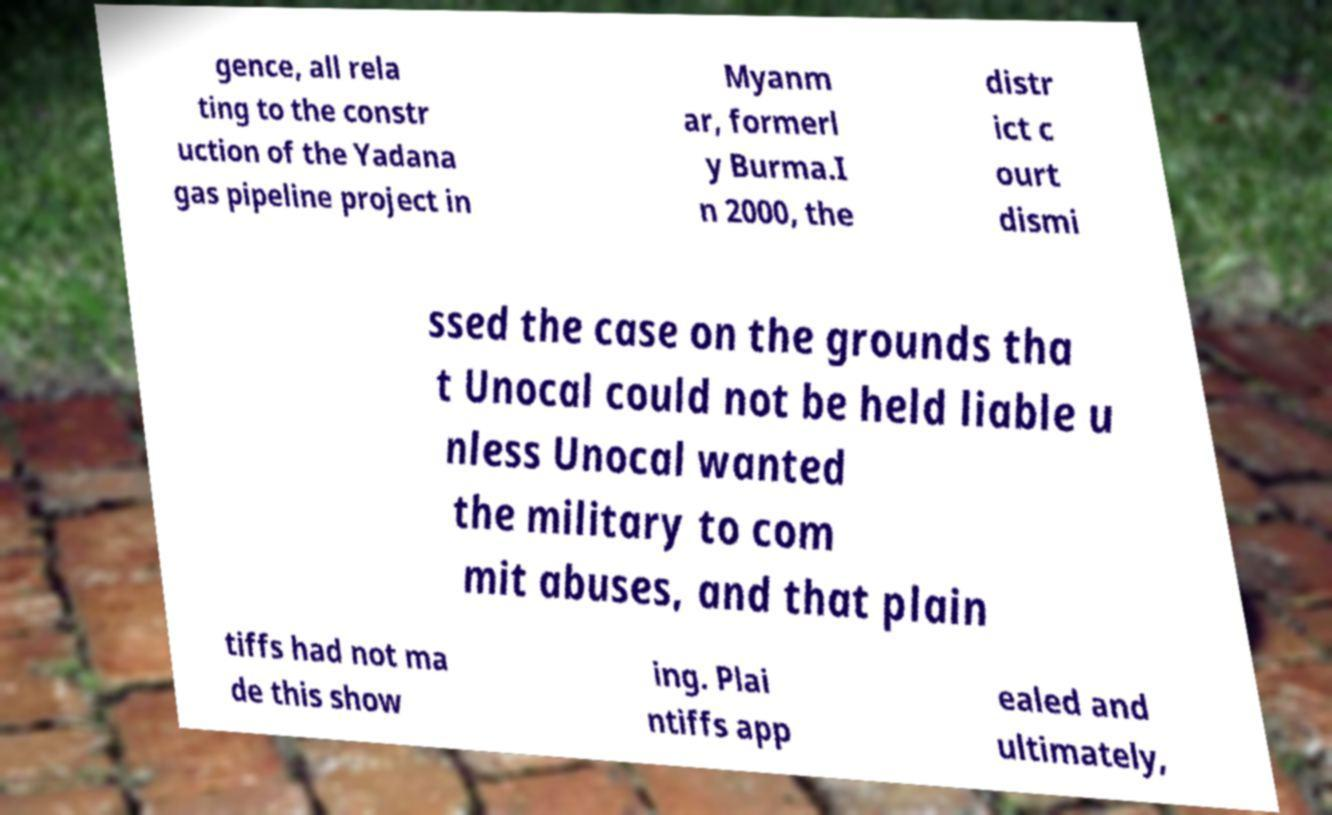What messages or text are displayed in this image? I need them in a readable, typed format. gence, all rela ting to the constr uction of the Yadana gas pipeline project in Myanm ar, formerl y Burma.I n 2000, the distr ict c ourt dismi ssed the case on the grounds tha t Unocal could not be held liable u nless Unocal wanted the military to com mit abuses, and that plain tiffs had not ma de this show ing. Plai ntiffs app ealed and ultimately, 